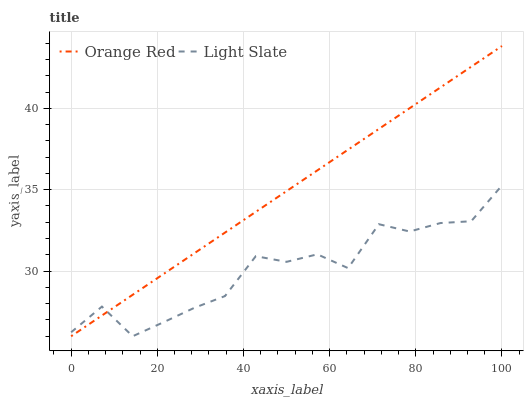Does Light Slate have the minimum area under the curve?
Answer yes or no. Yes. Does Orange Red have the maximum area under the curve?
Answer yes or no. Yes. Does Orange Red have the minimum area under the curve?
Answer yes or no. No. Is Orange Red the smoothest?
Answer yes or no. Yes. Is Light Slate the roughest?
Answer yes or no. Yes. Is Orange Red the roughest?
Answer yes or no. No. Does Orange Red have the highest value?
Answer yes or no. Yes. Does Orange Red intersect Light Slate?
Answer yes or no. Yes. Is Orange Red less than Light Slate?
Answer yes or no. No. Is Orange Red greater than Light Slate?
Answer yes or no. No. 